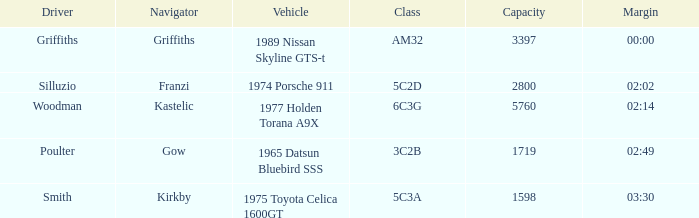What is the lowest capacity for the 1975 toyota celica 1600gt? 1598.0. 